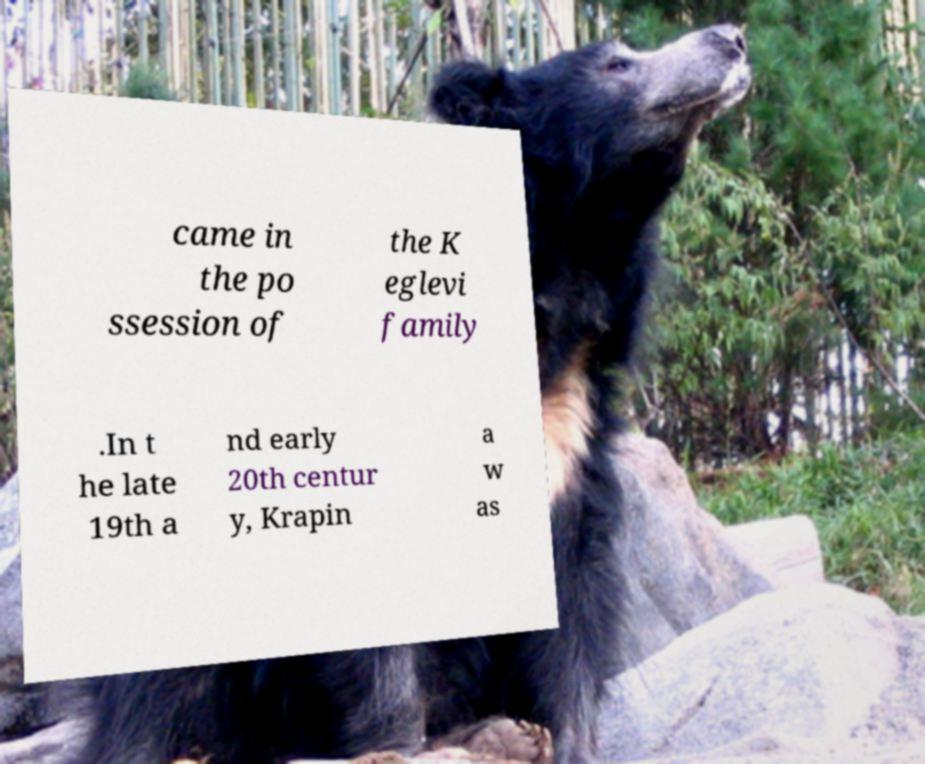Could you assist in decoding the text presented in this image and type it out clearly? came in the po ssession of the K eglevi family .In t he late 19th a nd early 20th centur y, Krapin a w as 